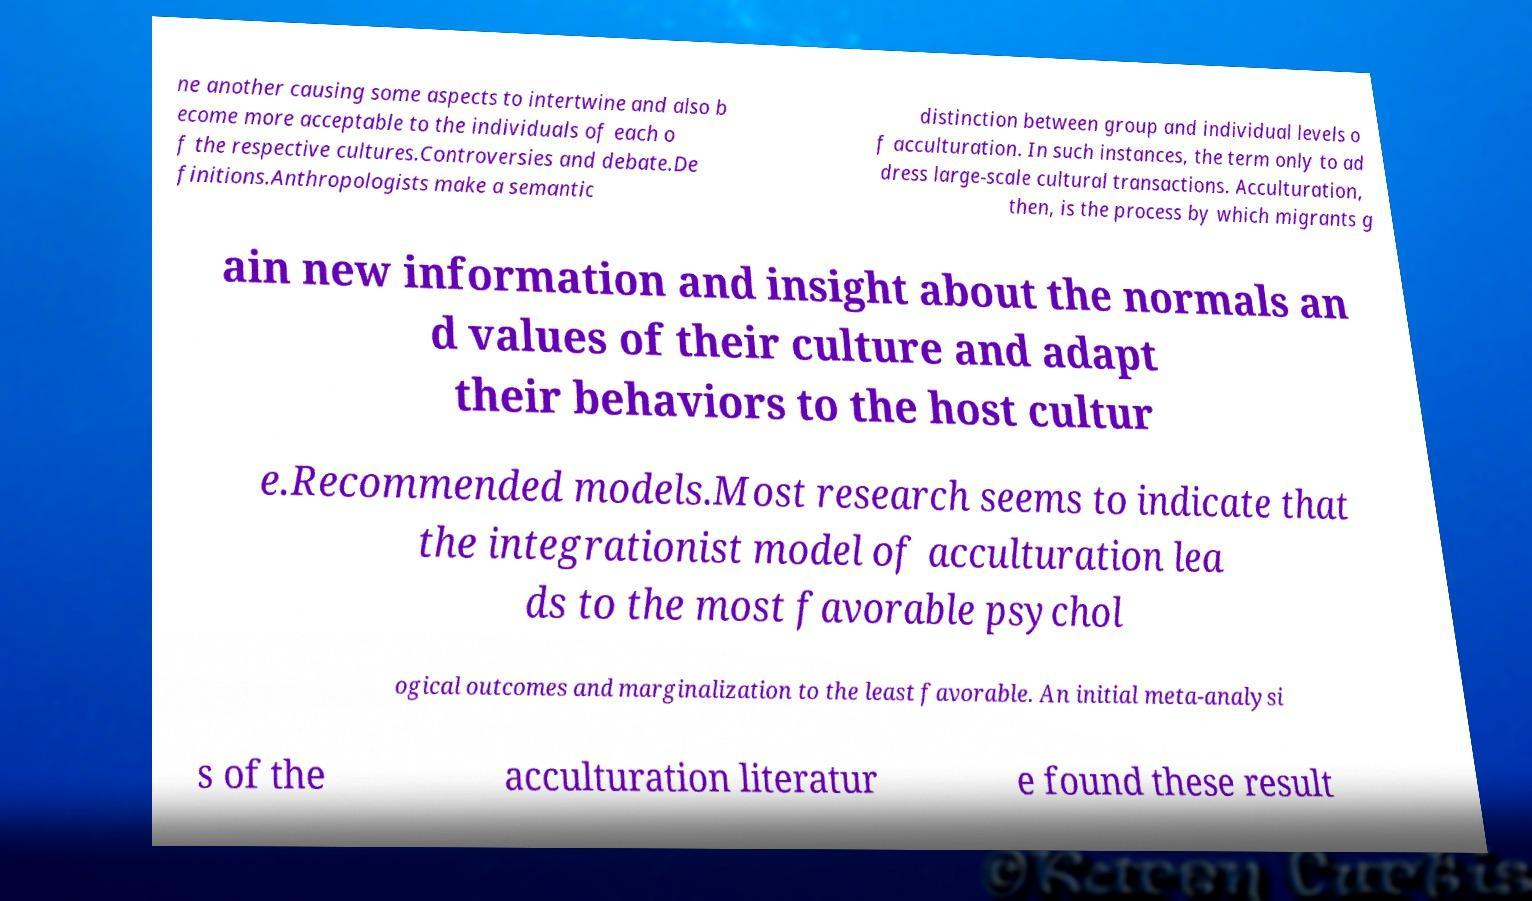There's text embedded in this image that I need extracted. Can you transcribe it verbatim? ne another causing some aspects to intertwine and also b ecome more acceptable to the individuals of each o f the respective cultures.Controversies and debate.De finitions.Anthropologists make a semantic distinction between group and individual levels o f acculturation. In such instances, the term only to ad dress large-scale cultural transactions. Acculturation, then, is the process by which migrants g ain new information and insight about the normals an d values of their culture and adapt their behaviors to the host cultur e.Recommended models.Most research seems to indicate that the integrationist model of acculturation lea ds to the most favorable psychol ogical outcomes and marginalization to the least favorable. An initial meta-analysi s of the acculturation literatur e found these result 